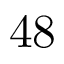Convert formula to latex. <formula><loc_0><loc_0><loc_500><loc_500>4 8</formula> 